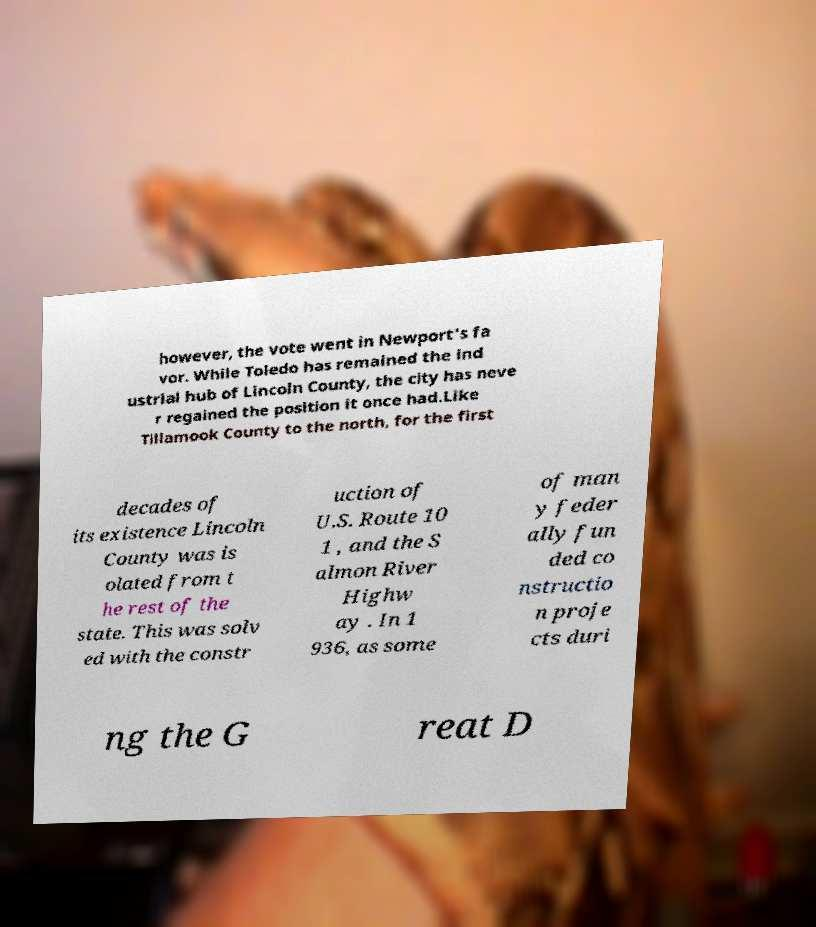Can you accurately transcribe the text from the provided image for me? however, the vote went in Newport's fa vor. While Toledo has remained the ind ustrial hub of Lincoln County, the city has neve r regained the position it once had.Like Tillamook County to the north, for the first decades of its existence Lincoln County was is olated from t he rest of the state. This was solv ed with the constr uction of U.S. Route 10 1 , and the S almon River Highw ay . In 1 936, as some of man y feder ally fun ded co nstructio n proje cts duri ng the G reat D 